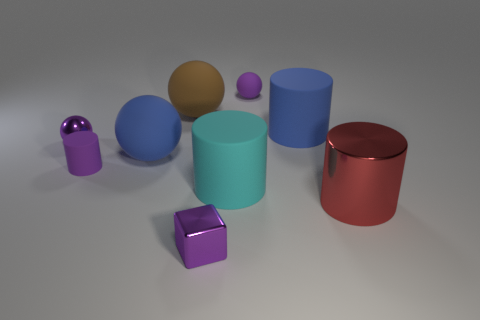Subtract all brown matte balls. How many balls are left? 3 Add 1 small green shiny cubes. How many objects exist? 10 Subtract all blue spheres. How many spheres are left? 3 Add 5 large blue objects. How many large blue objects exist? 7 Subtract 1 purple cylinders. How many objects are left? 8 Subtract all cylinders. How many objects are left? 5 Subtract 1 spheres. How many spheres are left? 3 Subtract all red spheres. Subtract all purple cylinders. How many spheres are left? 4 Subtract all yellow blocks. How many gray cylinders are left? 0 Subtract all blue spheres. Subtract all cyan things. How many objects are left? 7 